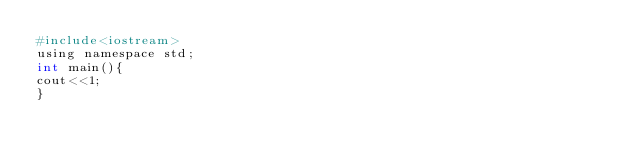Convert code to text. <code><loc_0><loc_0><loc_500><loc_500><_Awk_>#include<iostream>
using namespace std;
int main(){
cout<<1;
}</code> 